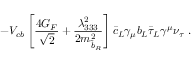Convert formula to latex. <formula><loc_0><loc_0><loc_500><loc_500>- V _ { c b } \left [ \frac { 4 G _ { F } } { \sqrt { 2 } } + \frac { \lambda _ { 3 3 3 } ^ { 2 } } { 2 m _ { \tilde { b } _ { R } } ^ { 2 } } \right ] \bar { c } _ { L } \gamma _ { \mu } b _ { L } \bar { \tau } _ { L } \gamma ^ { \mu } \nu _ { \tau } \ .</formula> 